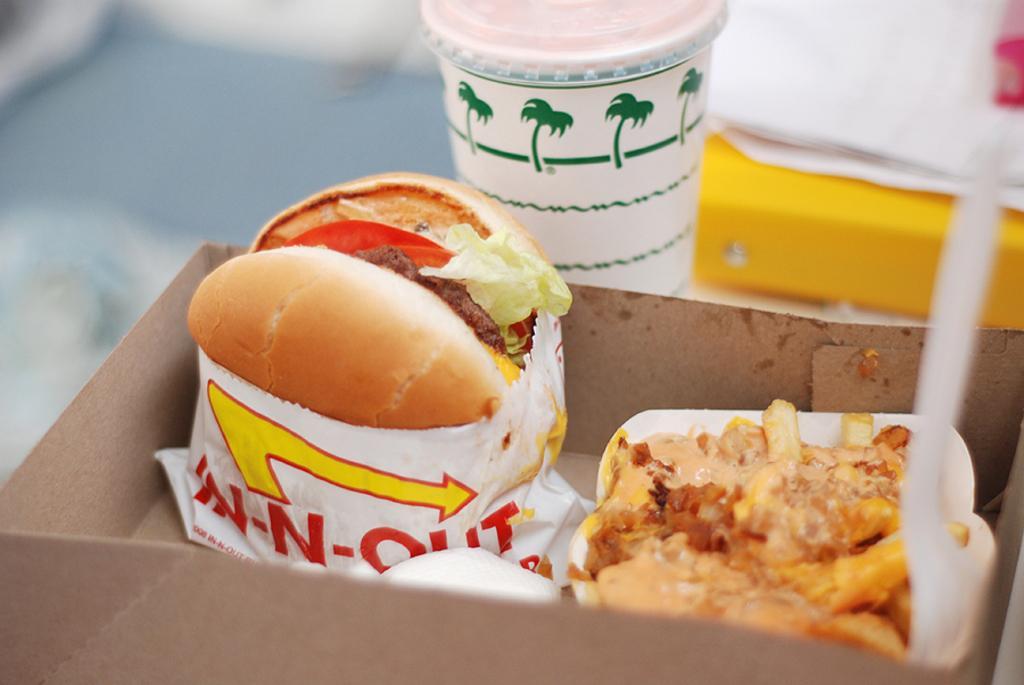Describe this image in one or two sentences. In this image we can see a burger and a sandwich in a box. We can also see a glass with a lid placed on the table. 